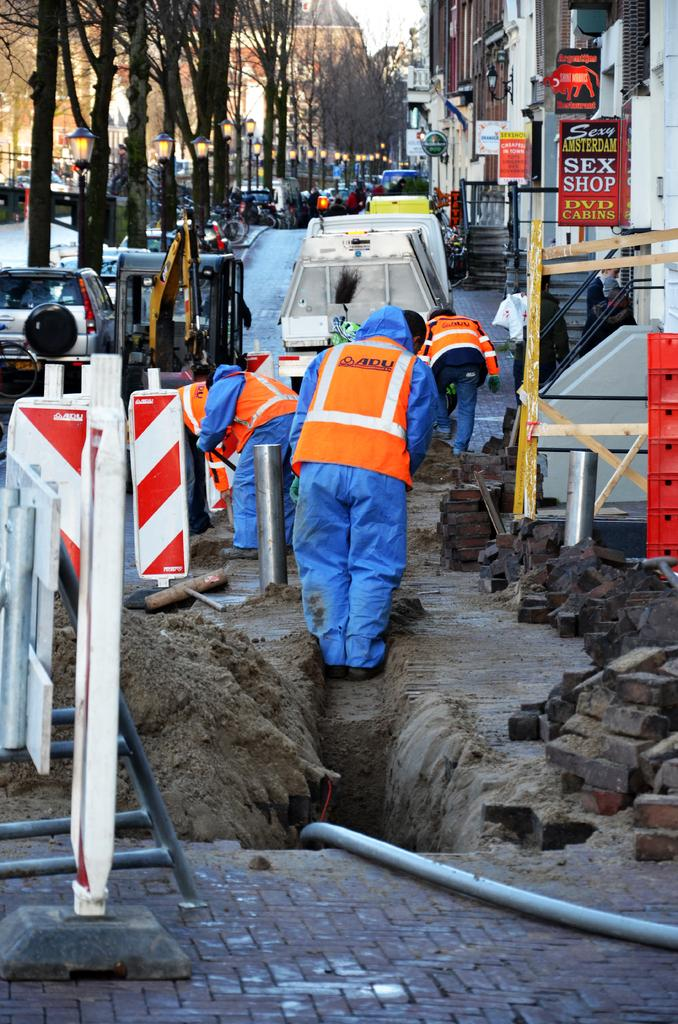What is the main feature of the image? There is a path in the image. What are the people doing in the image? People are digging the path. What type of vehicles can be seen in the image? There are cars in the image. What natural elements are present in the image? Trees are present in the image. What man-made structures can be seen in the image? There are buildings in the image. What material is being used to construct the path? Bricks are visible in the image. What other object is present in the image related to construction or infrastructure? A pipe is present in the image. What is the impulse of the taste of the trees in the image? There is no taste associated with the trees in the image, as they are not edible. Who is the owner of the pipe in the image? There is no indication of ownership for the pipe in the image. 